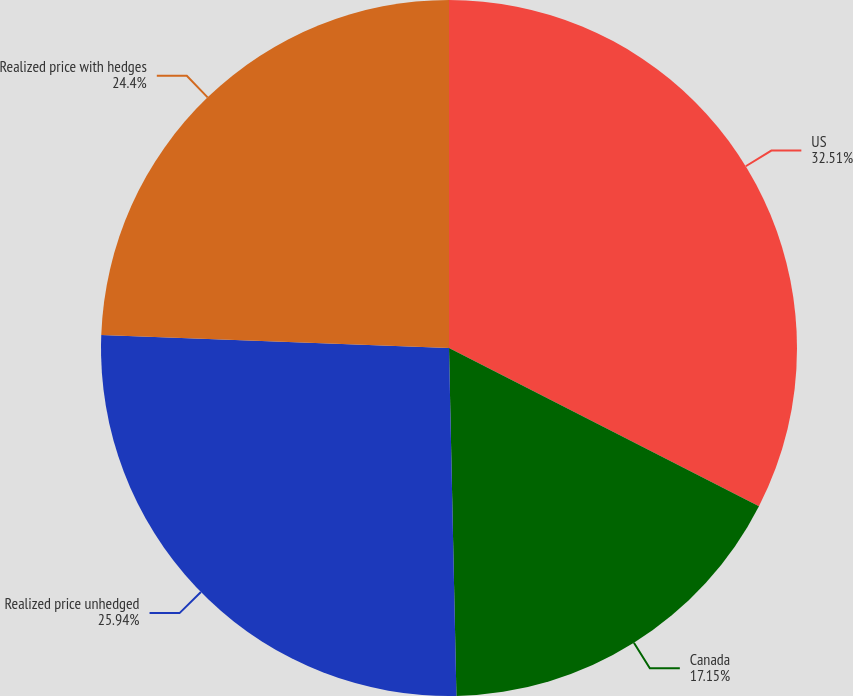<chart> <loc_0><loc_0><loc_500><loc_500><pie_chart><fcel>US<fcel>Canada<fcel>Realized price unhedged<fcel>Realized price with hedges<nl><fcel>32.51%<fcel>17.15%<fcel>25.94%<fcel>24.4%<nl></chart> 